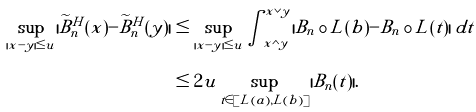<formula> <loc_0><loc_0><loc_500><loc_500>\sup _ { | x - y | \leq u } | \widetilde { B } _ { n } ^ { H } ( x ) - \widetilde { B } _ { n } ^ { H } ( y ) | & \leq \sup _ { | x - y | \leq u } \int _ { x \wedge y } ^ { x \vee y } | B _ { n } \circ L ( b ) - B _ { n } \circ L ( t ) | \, d t \\ & \leq 2 u \sup _ { t \in [ L ( a ) , L ( b ) ] } | B _ { n } ( t ) | .</formula> 